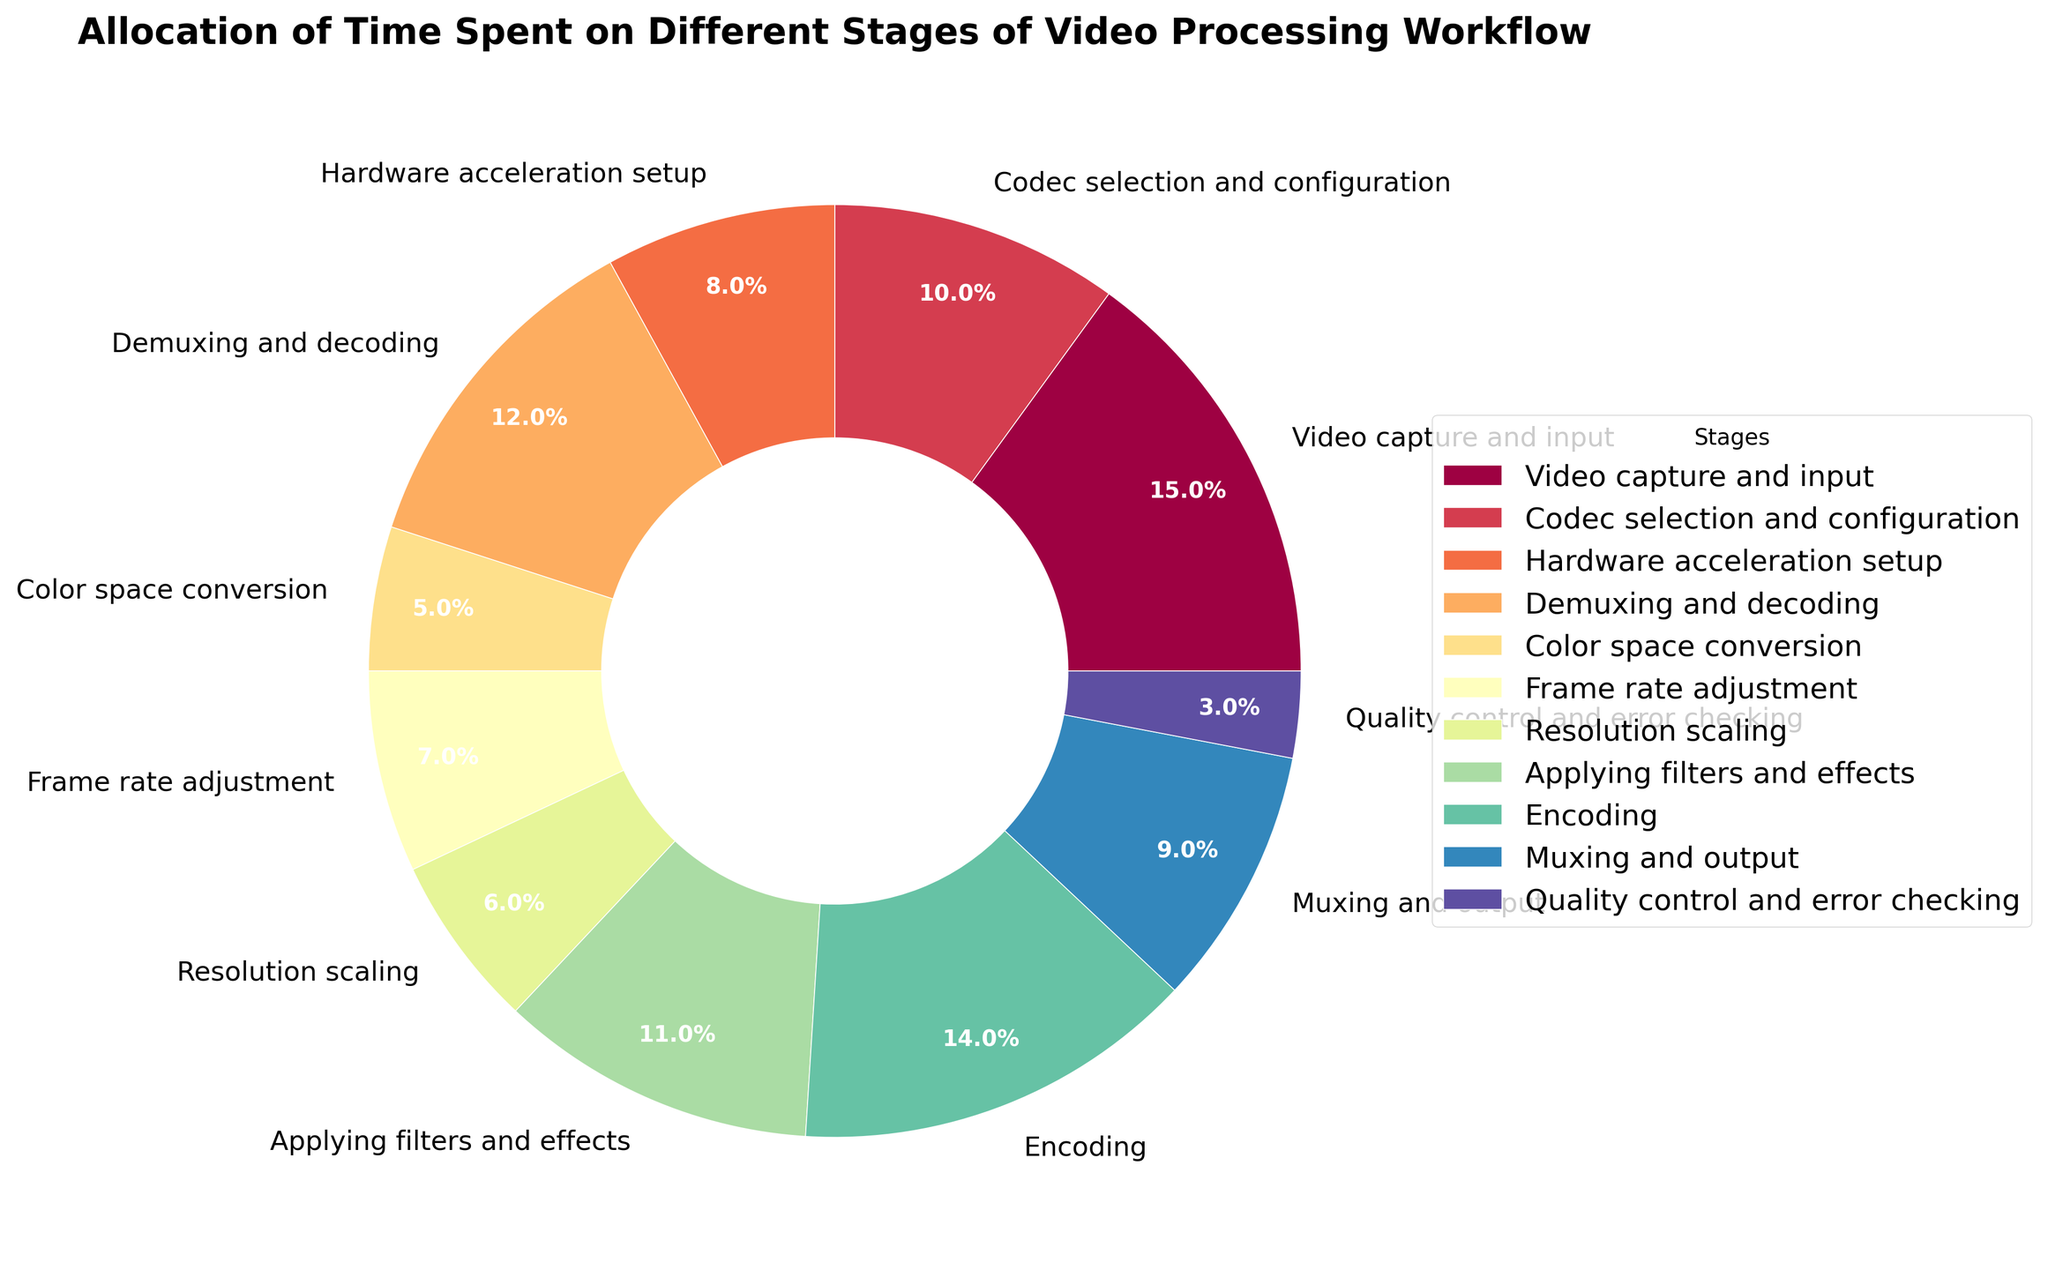What's the total percentage of time spent on video capture and input, codec selection and configuration, and hardware acceleration setup? To find the total percentage, add the percentages of these stages: Video capture and input (15%), Codec selection and configuration (10%), Hardware acceleration setup (8%). Therefore, the total percentage is 15% + 10% + 8% = 33%.
Answer: 33% Which stage takes a larger percentage of time, encoding or muxing and output? Compare the percentages for encoding (14%) and muxing and output (9%). Encoding (14%) is larger than muxing and output (9%).
Answer: Encoding What is the smallest percentage shown in the chart and which stage does it represent? The smallest percentage is 3%, which represents the stage for Quality control and error checking.
Answer: Quality control and error checking Which color corresponds to the stage of demuxing and decoding? The stage of demuxing and decoding is labeled on the pie chart and is associated with a specific color in the legend. Identify the color in the visual representation.
Answer: (color as per actual visualization, e.g., "yellow") What is the combined percentage of time spent on resolution scaling and frame rate adjustment? Add the percentages spent on resolution scaling (6%) and frame rate adjustment (7%). The combined percentage is 6% + 7% = 13%.
Answer: 13% What is the difference in percentage between the stage with the highest time allocation and the stage with the lowest time allocation? Identify the highest percentage (Video capture and input at 15%) and the lowest percentage (Quality control and error checking at 3%). The difference is 15% - 3% = 12%.
Answer: 12% Among the stages involved in post-capture processes (demuxing and decoding, color space conversion, etc.), which one takes the most time? To find the answer, compare the percentages of post-capture stages: Demuxing and decoding (12%), Color space conversion (5%), Frame rate adjustment (7%), Resolution scaling (6%), Applying filters and effects (11%), Encoding (14%), Muxing and output (9%), and Quality control and error checking (3%). Encoding has the highest percentage at 14%.
Answer: Encoding How many stages have a time allocation percentage greater than or equal to 10%? Count the stages with time allocation percentages of 10% or more: Video capture and input (15%), Codec selection and configuration (10%), Demuxing and decoding (12%), Applying filters and effects (11%), Encoding (14%). There are 5 stages.
Answer: 5 What is the average percentage of time spent on the stages related to output processes (encoding and muxing and output)? To calculate the average percentage, add the percentages of encoding (14%) and muxing and output (9%) and divide by the number of stages (2). The average is (14% + 9%) / 2 = 11.5%.
Answer: 11.5% 